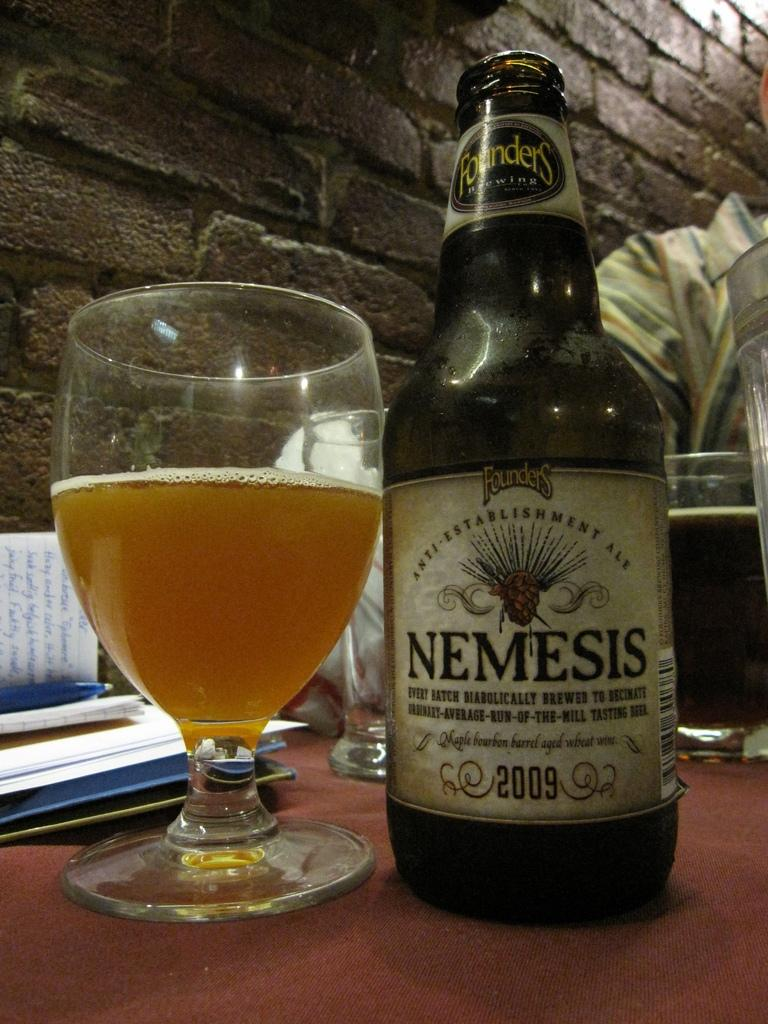Provide a one-sentence caption for the provided image. A bottle of Nemesis is next to a glass that is half full. 